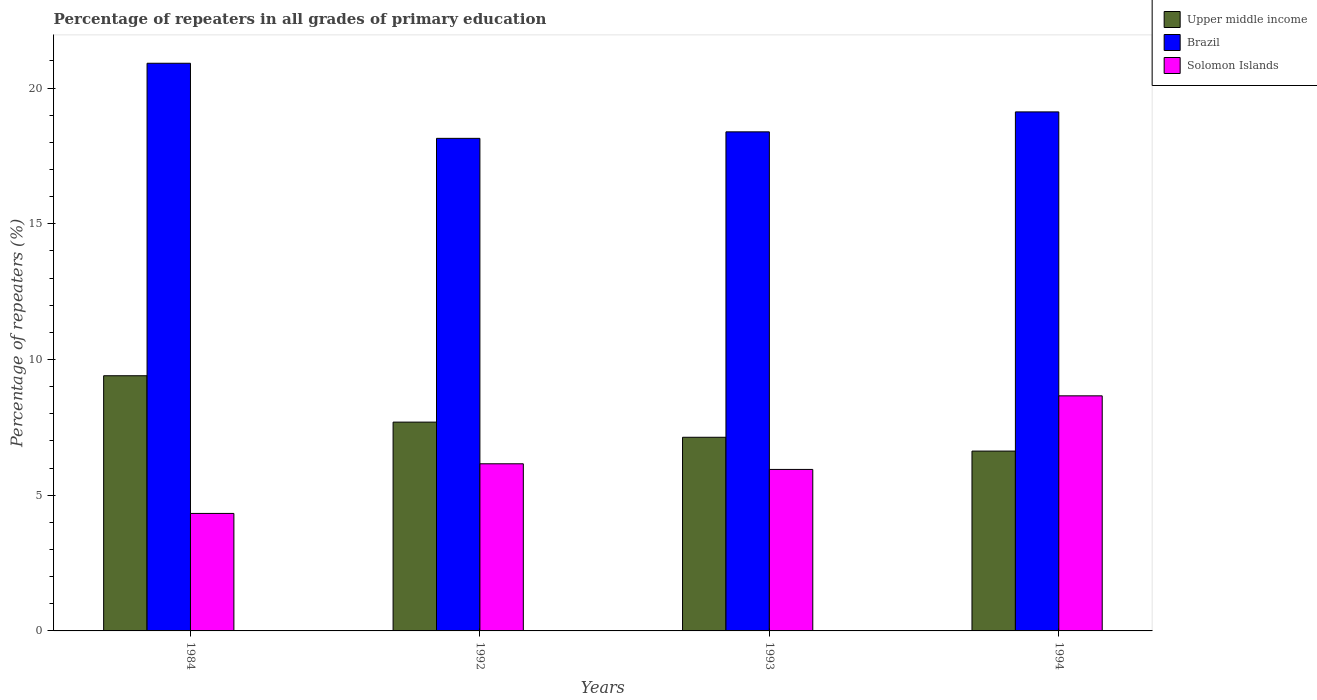Are the number of bars per tick equal to the number of legend labels?
Your answer should be compact. Yes. Are the number of bars on each tick of the X-axis equal?
Your answer should be very brief. Yes. How many bars are there on the 4th tick from the left?
Ensure brevity in your answer.  3. In how many cases, is the number of bars for a given year not equal to the number of legend labels?
Make the answer very short. 0. What is the percentage of repeaters in Solomon Islands in 1994?
Give a very brief answer. 8.66. Across all years, what is the maximum percentage of repeaters in Upper middle income?
Provide a short and direct response. 9.4. Across all years, what is the minimum percentage of repeaters in Solomon Islands?
Offer a very short reply. 4.33. In which year was the percentage of repeaters in Upper middle income maximum?
Keep it short and to the point. 1984. What is the total percentage of repeaters in Brazil in the graph?
Ensure brevity in your answer.  76.57. What is the difference between the percentage of repeaters in Upper middle income in 1993 and that in 1994?
Make the answer very short. 0.51. What is the difference between the percentage of repeaters in Solomon Islands in 1992 and the percentage of repeaters in Brazil in 1984?
Keep it short and to the point. -14.76. What is the average percentage of repeaters in Upper middle income per year?
Provide a short and direct response. 7.71. In the year 1992, what is the difference between the percentage of repeaters in Brazil and percentage of repeaters in Upper middle income?
Provide a short and direct response. 10.45. What is the ratio of the percentage of repeaters in Upper middle income in 1992 to that in 1993?
Your answer should be compact. 1.08. Is the percentage of repeaters in Brazil in 1992 less than that in 1994?
Offer a very short reply. Yes. Is the difference between the percentage of repeaters in Brazil in 1992 and 1994 greater than the difference between the percentage of repeaters in Upper middle income in 1992 and 1994?
Keep it short and to the point. No. What is the difference between the highest and the second highest percentage of repeaters in Upper middle income?
Provide a succinct answer. 1.71. What is the difference between the highest and the lowest percentage of repeaters in Solomon Islands?
Make the answer very short. 4.33. In how many years, is the percentage of repeaters in Solomon Islands greater than the average percentage of repeaters in Solomon Islands taken over all years?
Give a very brief answer. 1. What does the 3rd bar from the left in 1993 represents?
Provide a succinct answer. Solomon Islands. What does the 3rd bar from the right in 1994 represents?
Provide a succinct answer. Upper middle income. Is it the case that in every year, the sum of the percentage of repeaters in Brazil and percentage of repeaters in Upper middle income is greater than the percentage of repeaters in Solomon Islands?
Ensure brevity in your answer.  Yes. Are the values on the major ticks of Y-axis written in scientific E-notation?
Provide a succinct answer. No. Does the graph contain any zero values?
Provide a short and direct response. No. Does the graph contain grids?
Offer a terse response. No. How are the legend labels stacked?
Keep it short and to the point. Vertical. What is the title of the graph?
Your response must be concise. Percentage of repeaters in all grades of primary education. What is the label or title of the X-axis?
Your response must be concise. Years. What is the label or title of the Y-axis?
Offer a terse response. Percentage of repeaters (%). What is the Percentage of repeaters (%) of Upper middle income in 1984?
Provide a succinct answer. 9.4. What is the Percentage of repeaters (%) in Brazil in 1984?
Give a very brief answer. 20.91. What is the Percentage of repeaters (%) of Solomon Islands in 1984?
Provide a succinct answer. 4.33. What is the Percentage of repeaters (%) in Upper middle income in 1992?
Provide a short and direct response. 7.69. What is the Percentage of repeaters (%) of Brazil in 1992?
Keep it short and to the point. 18.15. What is the Percentage of repeaters (%) of Solomon Islands in 1992?
Give a very brief answer. 6.16. What is the Percentage of repeaters (%) in Upper middle income in 1993?
Offer a terse response. 7.13. What is the Percentage of repeaters (%) of Brazil in 1993?
Provide a short and direct response. 18.39. What is the Percentage of repeaters (%) in Solomon Islands in 1993?
Offer a terse response. 5.95. What is the Percentage of repeaters (%) in Upper middle income in 1994?
Offer a terse response. 6.63. What is the Percentage of repeaters (%) in Brazil in 1994?
Ensure brevity in your answer.  19.12. What is the Percentage of repeaters (%) of Solomon Islands in 1994?
Give a very brief answer. 8.66. Across all years, what is the maximum Percentage of repeaters (%) in Upper middle income?
Provide a short and direct response. 9.4. Across all years, what is the maximum Percentage of repeaters (%) in Brazil?
Provide a succinct answer. 20.91. Across all years, what is the maximum Percentage of repeaters (%) in Solomon Islands?
Provide a succinct answer. 8.66. Across all years, what is the minimum Percentage of repeaters (%) in Upper middle income?
Your answer should be very brief. 6.63. Across all years, what is the minimum Percentage of repeaters (%) of Brazil?
Make the answer very short. 18.15. Across all years, what is the minimum Percentage of repeaters (%) in Solomon Islands?
Provide a short and direct response. 4.33. What is the total Percentage of repeaters (%) of Upper middle income in the graph?
Offer a terse response. 30.85. What is the total Percentage of repeaters (%) of Brazil in the graph?
Offer a very short reply. 76.57. What is the total Percentage of repeaters (%) in Solomon Islands in the graph?
Keep it short and to the point. 25.1. What is the difference between the Percentage of repeaters (%) of Upper middle income in 1984 and that in 1992?
Make the answer very short. 1.71. What is the difference between the Percentage of repeaters (%) of Brazil in 1984 and that in 1992?
Ensure brevity in your answer.  2.77. What is the difference between the Percentage of repeaters (%) of Solomon Islands in 1984 and that in 1992?
Give a very brief answer. -1.83. What is the difference between the Percentage of repeaters (%) in Upper middle income in 1984 and that in 1993?
Provide a succinct answer. 2.27. What is the difference between the Percentage of repeaters (%) in Brazil in 1984 and that in 1993?
Your answer should be very brief. 2.53. What is the difference between the Percentage of repeaters (%) of Solomon Islands in 1984 and that in 1993?
Your answer should be very brief. -1.62. What is the difference between the Percentage of repeaters (%) in Upper middle income in 1984 and that in 1994?
Offer a very short reply. 2.78. What is the difference between the Percentage of repeaters (%) in Brazil in 1984 and that in 1994?
Your answer should be very brief. 1.79. What is the difference between the Percentage of repeaters (%) of Solomon Islands in 1984 and that in 1994?
Offer a very short reply. -4.33. What is the difference between the Percentage of repeaters (%) of Upper middle income in 1992 and that in 1993?
Offer a terse response. 0.56. What is the difference between the Percentage of repeaters (%) in Brazil in 1992 and that in 1993?
Give a very brief answer. -0.24. What is the difference between the Percentage of repeaters (%) of Solomon Islands in 1992 and that in 1993?
Give a very brief answer. 0.21. What is the difference between the Percentage of repeaters (%) of Upper middle income in 1992 and that in 1994?
Offer a very short reply. 1.07. What is the difference between the Percentage of repeaters (%) in Brazil in 1992 and that in 1994?
Keep it short and to the point. -0.97. What is the difference between the Percentage of repeaters (%) of Solomon Islands in 1992 and that in 1994?
Ensure brevity in your answer.  -2.5. What is the difference between the Percentage of repeaters (%) of Upper middle income in 1993 and that in 1994?
Ensure brevity in your answer.  0.51. What is the difference between the Percentage of repeaters (%) of Brazil in 1993 and that in 1994?
Give a very brief answer. -0.73. What is the difference between the Percentage of repeaters (%) in Solomon Islands in 1993 and that in 1994?
Your response must be concise. -2.71. What is the difference between the Percentage of repeaters (%) of Upper middle income in 1984 and the Percentage of repeaters (%) of Brazil in 1992?
Provide a short and direct response. -8.75. What is the difference between the Percentage of repeaters (%) of Upper middle income in 1984 and the Percentage of repeaters (%) of Solomon Islands in 1992?
Keep it short and to the point. 3.24. What is the difference between the Percentage of repeaters (%) of Brazil in 1984 and the Percentage of repeaters (%) of Solomon Islands in 1992?
Offer a terse response. 14.76. What is the difference between the Percentage of repeaters (%) in Upper middle income in 1984 and the Percentage of repeaters (%) in Brazil in 1993?
Offer a terse response. -8.98. What is the difference between the Percentage of repeaters (%) of Upper middle income in 1984 and the Percentage of repeaters (%) of Solomon Islands in 1993?
Keep it short and to the point. 3.45. What is the difference between the Percentage of repeaters (%) in Brazil in 1984 and the Percentage of repeaters (%) in Solomon Islands in 1993?
Provide a short and direct response. 14.96. What is the difference between the Percentage of repeaters (%) of Upper middle income in 1984 and the Percentage of repeaters (%) of Brazil in 1994?
Keep it short and to the point. -9.72. What is the difference between the Percentage of repeaters (%) of Upper middle income in 1984 and the Percentage of repeaters (%) of Solomon Islands in 1994?
Your answer should be very brief. 0.74. What is the difference between the Percentage of repeaters (%) in Brazil in 1984 and the Percentage of repeaters (%) in Solomon Islands in 1994?
Provide a succinct answer. 12.25. What is the difference between the Percentage of repeaters (%) of Upper middle income in 1992 and the Percentage of repeaters (%) of Brazil in 1993?
Offer a very short reply. -10.69. What is the difference between the Percentage of repeaters (%) in Upper middle income in 1992 and the Percentage of repeaters (%) in Solomon Islands in 1993?
Keep it short and to the point. 1.74. What is the difference between the Percentage of repeaters (%) of Brazil in 1992 and the Percentage of repeaters (%) of Solomon Islands in 1993?
Your answer should be very brief. 12.2. What is the difference between the Percentage of repeaters (%) of Upper middle income in 1992 and the Percentage of repeaters (%) of Brazil in 1994?
Your answer should be compact. -11.43. What is the difference between the Percentage of repeaters (%) in Upper middle income in 1992 and the Percentage of repeaters (%) in Solomon Islands in 1994?
Your answer should be compact. -0.97. What is the difference between the Percentage of repeaters (%) in Brazil in 1992 and the Percentage of repeaters (%) in Solomon Islands in 1994?
Offer a very short reply. 9.49. What is the difference between the Percentage of repeaters (%) in Upper middle income in 1993 and the Percentage of repeaters (%) in Brazil in 1994?
Keep it short and to the point. -11.99. What is the difference between the Percentage of repeaters (%) of Upper middle income in 1993 and the Percentage of repeaters (%) of Solomon Islands in 1994?
Make the answer very short. -1.53. What is the difference between the Percentage of repeaters (%) in Brazil in 1993 and the Percentage of repeaters (%) in Solomon Islands in 1994?
Offer a terse response. 9.73. What is the average Percentage of repeaters (%) in Upper middle income per year?
Your answer should be very brief. 7.71. What is the average Percentage of repeaters (%) in Brazil per year?
Your answer should be very brief. 19.14. What is the average Percentage of repeaters (%) in Solomon Islands per year?
Your response must be concise. 6.27. In the year 1984, what is the difference between the Percentage of repeaters (%) of Upper middle income and Percentage of repeaters (%) of Brazil?
Offer a very short reply. -11.51. In the year 1984, what is the difference between the Percentage of repeaters (%) of Upper middle income and Percentage of repeaters (%) of Solomon Islands?
Make the answer very short. 5.07. In the year 1984, what is the difference between the Percentage of repeaters (%) of Brazil and Percentage of repeaters (%) of Solomon Islands?
Offer a very short reply. 16.58. In the year 1992, what is the difference between the Percentage of repeaters (%) in Upper middle income and Percentage of repeaters (%) in Brazil?
Provide a succinct answer. -10.45. In the year 1992, what is the difference between the Percentage of repeaters (%) in Upper middle income and Percentage of repeaters (%) in Solomon Islands?
Your response must be concise. 1.54. In the year 1992, what is the difference between the Percentage of repeaters (%) of Brazil and Percentage of repeaters (%) of Solomon Islands?
Offer a terse response. 11.99. In the year 1993, what is the difference between the Percentage of repeaters (%) in Upper middle income and Percentage of repeaters (%) in Brazil?
Your response must be concise. -11.25. In the year 1993, what is the difference between the Percentage of repeaters (%) of Upper middle income and Percentage of repeaters (%) of Solomon Islands?
Provide a succinct answer. 1.18. In the year 1993, what is the difference between the Percentage of repeaters (%) in Brazil and Percentage of repeaters (%) in Solomon Islands?
Offer a very short reply. 12.44. In the year 1994, what is the difference between the Percentage of repeaters (%) of Upper middle income and Percentage of repeaters (%) of Brazil?
Keep it short and to the point. -12.5. In the year 1994, what is the difference between the Percentage of repeaters (%) in Upper middle income and Percentage of repeaters (%) in Solomon Islands?
Provide a short and direct response. -2.04. In the year 1994, what is the difference between the Percentage of repeaters (%) in Brazil and Percentage of repeaters (%) in Solomon Islands?
Your response must be concise. 10.46. What is the ratio of the Percentage of repeaters (%) in Upper middle income in 1984 to that in 1992?
Your answer should be compact. 1.22. What is the ratio of the Percentage of repeaters (%) of Brazil in 1984 to that in 1992?
Keep it short and to the point. 1.15. What is the ratio of the Percentage of repeaters (%) of Solomon Islands in 1984 to that in 1992?
Ensure brevity in your answer.  0.7. What is the ratio of the Percentage of repeaters (%) in Upper middle income in 1984 to that in 1993?
Your answer should be compact. 1.32. What is the ratio of the Percentage of repeaters (%) in Brazil in 1984 to that in 1993?
Make the answer very short. 1.14. What is the ratio of the Percentage of repeaters (%) of Solomon Islands in 1984 to that in 1993?
Offer a very short reply. 0.73. What is the ratio of the Percentage of repeaters (%) of Upper middle income in 1984 to that in 1994?
Make the answer very short. 1.42. What is the ratio of the Percentage of repeaters (%) in Brazil in 1984 to that in 1994?
Offer a very short reply. 1.09. What is the ratio of the Percentage of repeaters (%) of Solomon Islands in 1984 to that in 1994?
Offer a terse response. 0.5. What is the ratio of the Percentage of repeaters (%) in Upper middle income in 1992 to that in 1993?
Your response must be concise. 1.08. What is the ratio of the Percentage of repeaters (%) of Solomon Islands in 1992 to that in 1993?
Your response must be concise. 1.03. What is the ratio of the Percentage of repeaters (%) of Upper middle income in 1992 to that in 1994?
Offer a terse response. 1.16. What is the ratio of the Percentage of repeaters (%) of Brazil in 1992 to that in 1994?
Keep it short and to the point. 0.95. What is the ratio of the Percentage of repeaters (%) of Solomon Islands in 1992 to that in 1994?
Ensure brevity in your answer.  0.71. What is the ratio of the Percentage of repeaters (%) in Upper middle income in 1993 to that in 1994?
Offer a terse response. 1.08. What is the ratio of the Percentage of repeaters (%) of Brazil in 1993 to that in 1994?
Your answer should be compact. 0.96. What is the ratio of the Percentage of repeaters (%) of Solomon Islands in 1993 to that in 1994?
Your response must be concise. 0.69. What is the difference between the highest and the second highest Percentage of repeaters (%) of Upper middle income?
Keep it short and to the point. 1.71. What is the difference between the highest and the second highest Percentage of repeaters (%) of Brazil?
Provide a short and direct response. 1.79. What is the difference between the highest and the second highest Percentage of repeaters (%) of Solomon Islands?
Ensure brevity in your answer.  2.5. What is the difference between the highest and the lowest Percentage of repeaters (%) in Upper middle income?
Provide a short and direct response. 2.78. What is the difference between the highest and the lowest Percentage of repeaters (%) of Brazil?
Keep it short and to the point. 2.77. What is the difference between the highest and the lowest Percentage of repeaters (%) in Solomon Islands?
Your response must be concise. 4.33. 